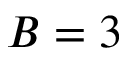<formula> <loc_0><loc_0><loc_500><loc_500>B = 3</formula> 